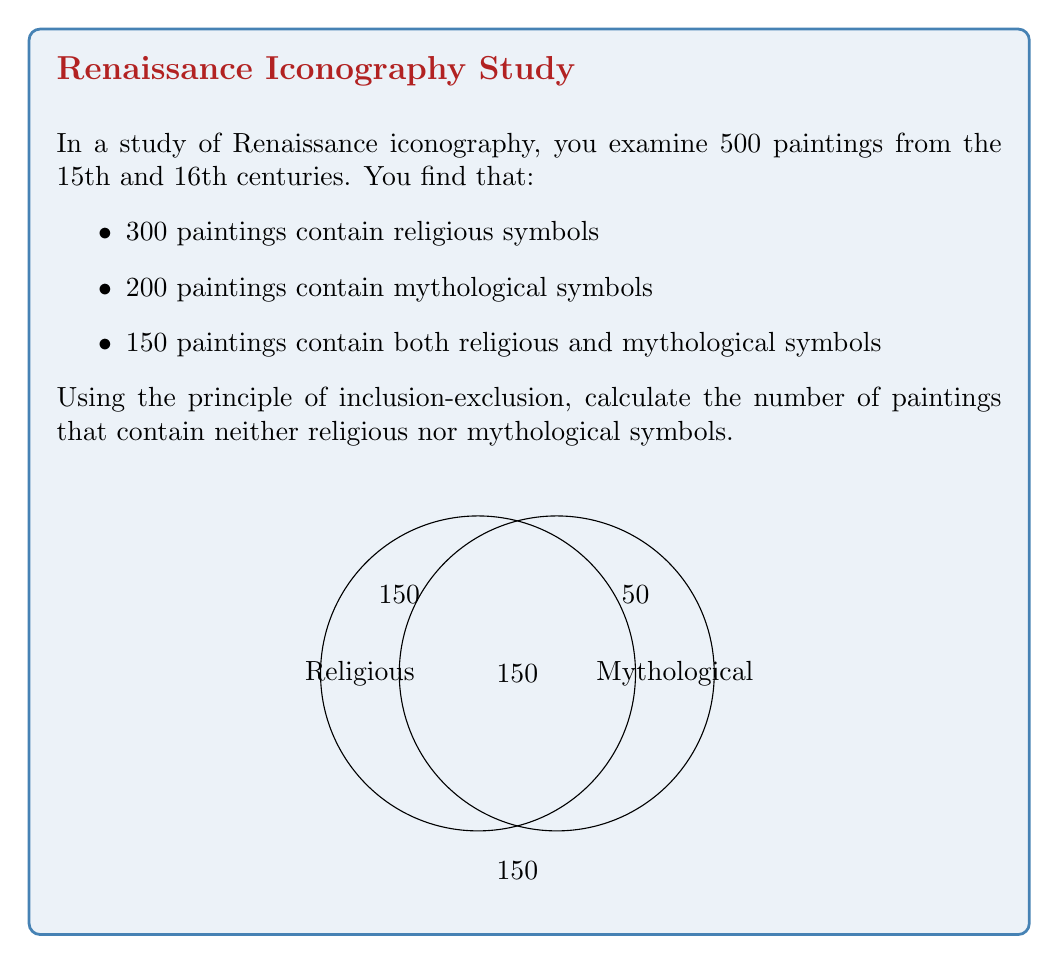Could you help me with this problem? Let's approach this step-by-step using the principle of inclusion-exclusion:

1) Let R be the set of paintings with religious symbols, and M be the set with mythological symbols.

2) We know:
   |R| = 300
   |M| = 200
   |R ∩ M| = 150 (paintings with both types of symbols)

3) We want to find the number of paintings with neither type of symbol. This is the complement of the set of paintings with at least one type of symbol.

4) The number of paintings with at least one type of symbol is given by:
   |R ∪ M| = |R| + |M| - |R ∩ M|

5) Substituting the values:
   |R ∪ M| = 300 + 200 - 150 = 350

6) The total number of paintings is 500, so the number of paintings with neither type of symbol is:
   500 - 350 = 150

Therefore, 150 paintings contain neither religious nor mythological symbols.
Answer: 150 